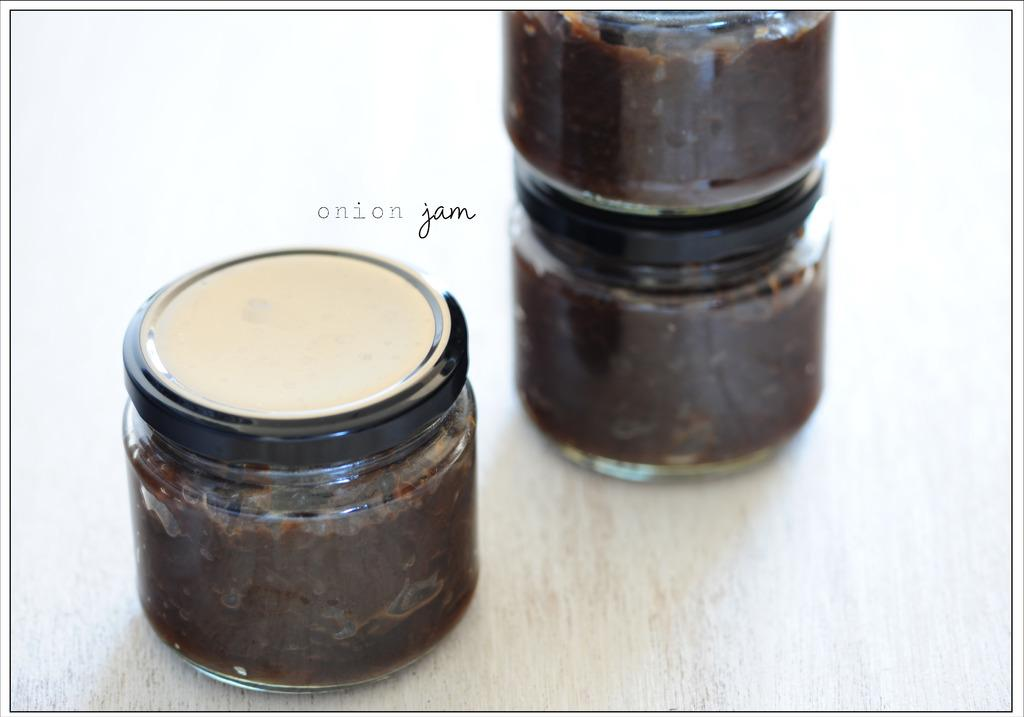<image>
Describe the image concisely. Three glass jars with lids with a substance inside is sitting on a table with a brand name onion jam. 